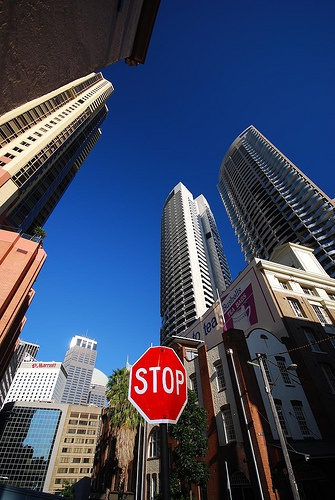Describe the objects in this image and their specific colors. I can see a stop sign in black, red, lightgray, brown, and lightpink tones in this image. 